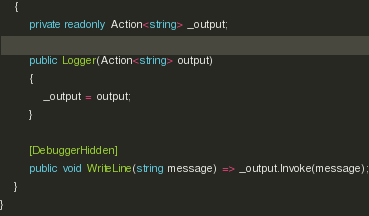Convert code to text. <code><loc_0><loc_0><loc_500><loc_500><_C#_>    {
        private readonly Action<string> _output;

        public Logger(Action<string> output)
        {
            _output = output;
        }

        [DebuggerHidden]
        public void WriteLine(string message) => _output.Invoke(message);
    }
}</code> 